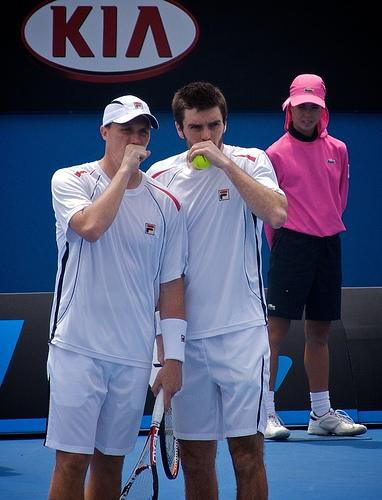Why are they covering their mouths? Please explain your reasoning. conceal conversation. They don't want the other team to hear their plans. they are dressed the same and are playing doubles. 